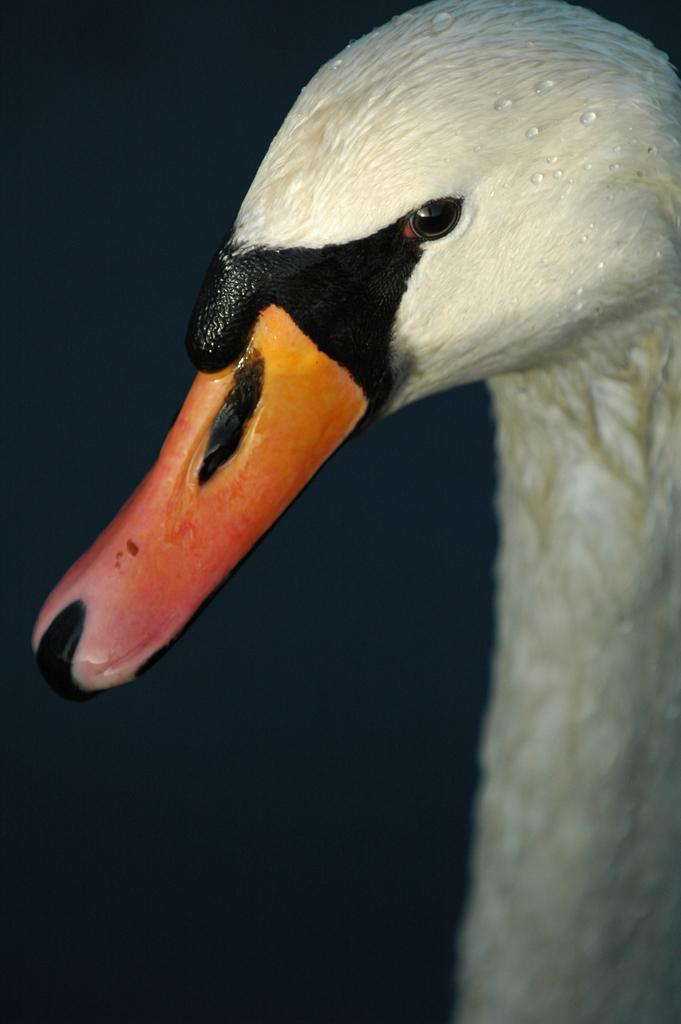What type of animal is in the image? There is a bird in the image. What colors can be seen on the bird? The bird has cream, black, orange, and red colors. What is the color of the background in the image? The background of the image is black. What type of haircut does the bird have in the image? There is no indication of a haircut in the image, as birds do not have hair. Is the bird holding an umbrella in the image? There is no umbrella present in the image. 